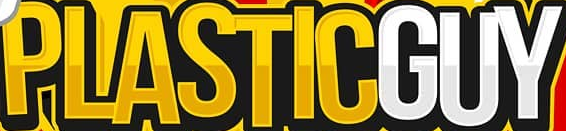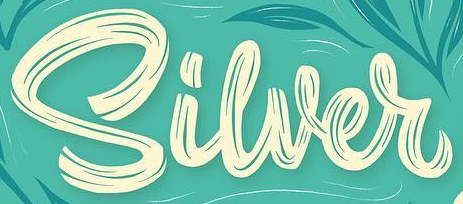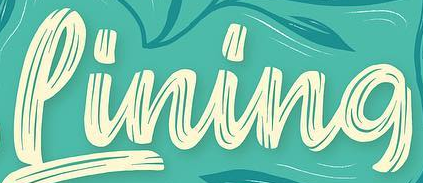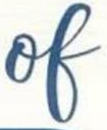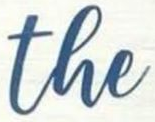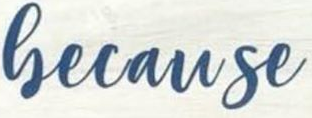What text is displayed in these images sequentially, separated by a semicolon? PLASTICGUY; Siwer; Pining; of; the; Gecause 